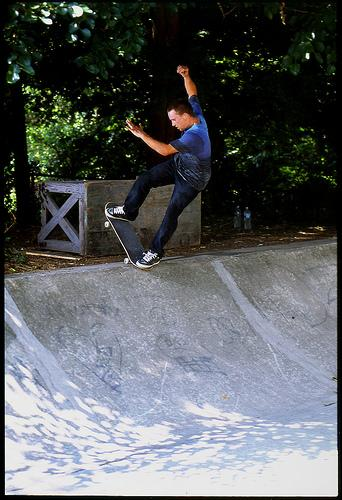How would you assess the quality of this image in terms of clarity and focus? The image has a clear focus on the central subject - the young male skateboarding - while maintaining a level of detail on the surrounding elements, providing overall good quality. Discuss the interaction between human and environment in this image. The man is riding a skateboard on a half pipe in a skateboard park, showcasing a connection between his physical activity and the built environment around him. List three objects related to the man's outfit. A blue shirt, blue jeans, and a pair of tennis shoes. Identify the type of place where this scene is happening and mention one specific element of it. This scene is happening in a concrete skateboard park, and there is graffiti painted on the concrete. Quantify the water bottles in the image and describe their position. There are two water bottles, and they are sitting on the ground next to each other. Are there any objects made of wood in the image? If so, specify one and its size. Yes, there is a wooden table on its side with a width of 182 and a height of 182. Express the emotion or feeling conveyed by the image. The image conveys a sense of exhilaration, freedom, and excitement related to skateboarding. What is the primary activity the young male is engaged in? The young male is engaged in riding a skateboard on a half pipe. 